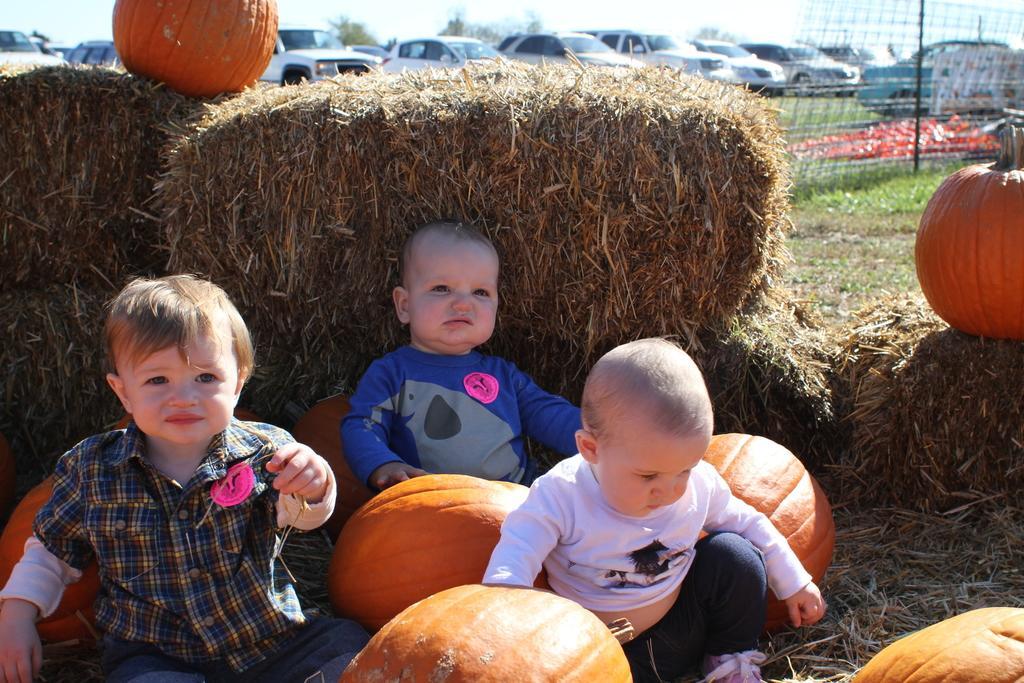Describe this image in one or two sentences. In this image I can see kids and pumpkins. In the background I can see fence, the grass, vehicles and the sky. 